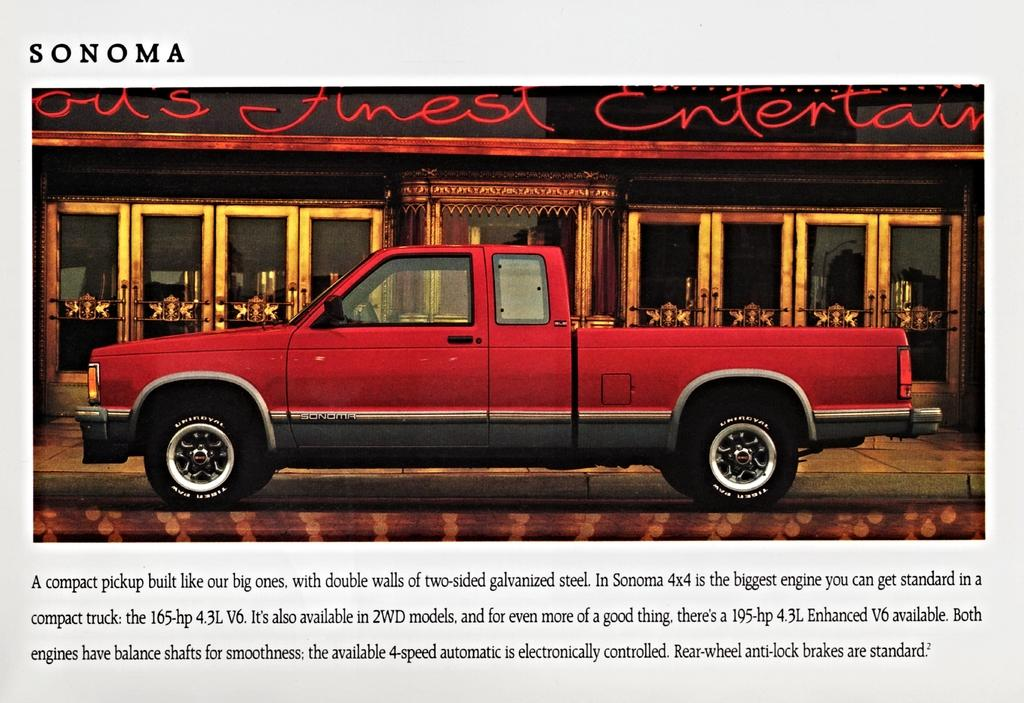What is the main object in the image? There is a magazine in the image. What is depicted on the cover of the magazine? The magazine has an image of a car. What can be seen behind the magazine in the image? There are doors visible behind the magazine. What additional information is provided on the magazine? There is some information below the image on the magazine. What type of plantation is shown in the image? There is no plantation present in the image; it features a magazine with an image of a car. How does the magazine feel regret in the image? Magazines do not have emotions like regret, so this question is not applicable to the image. 